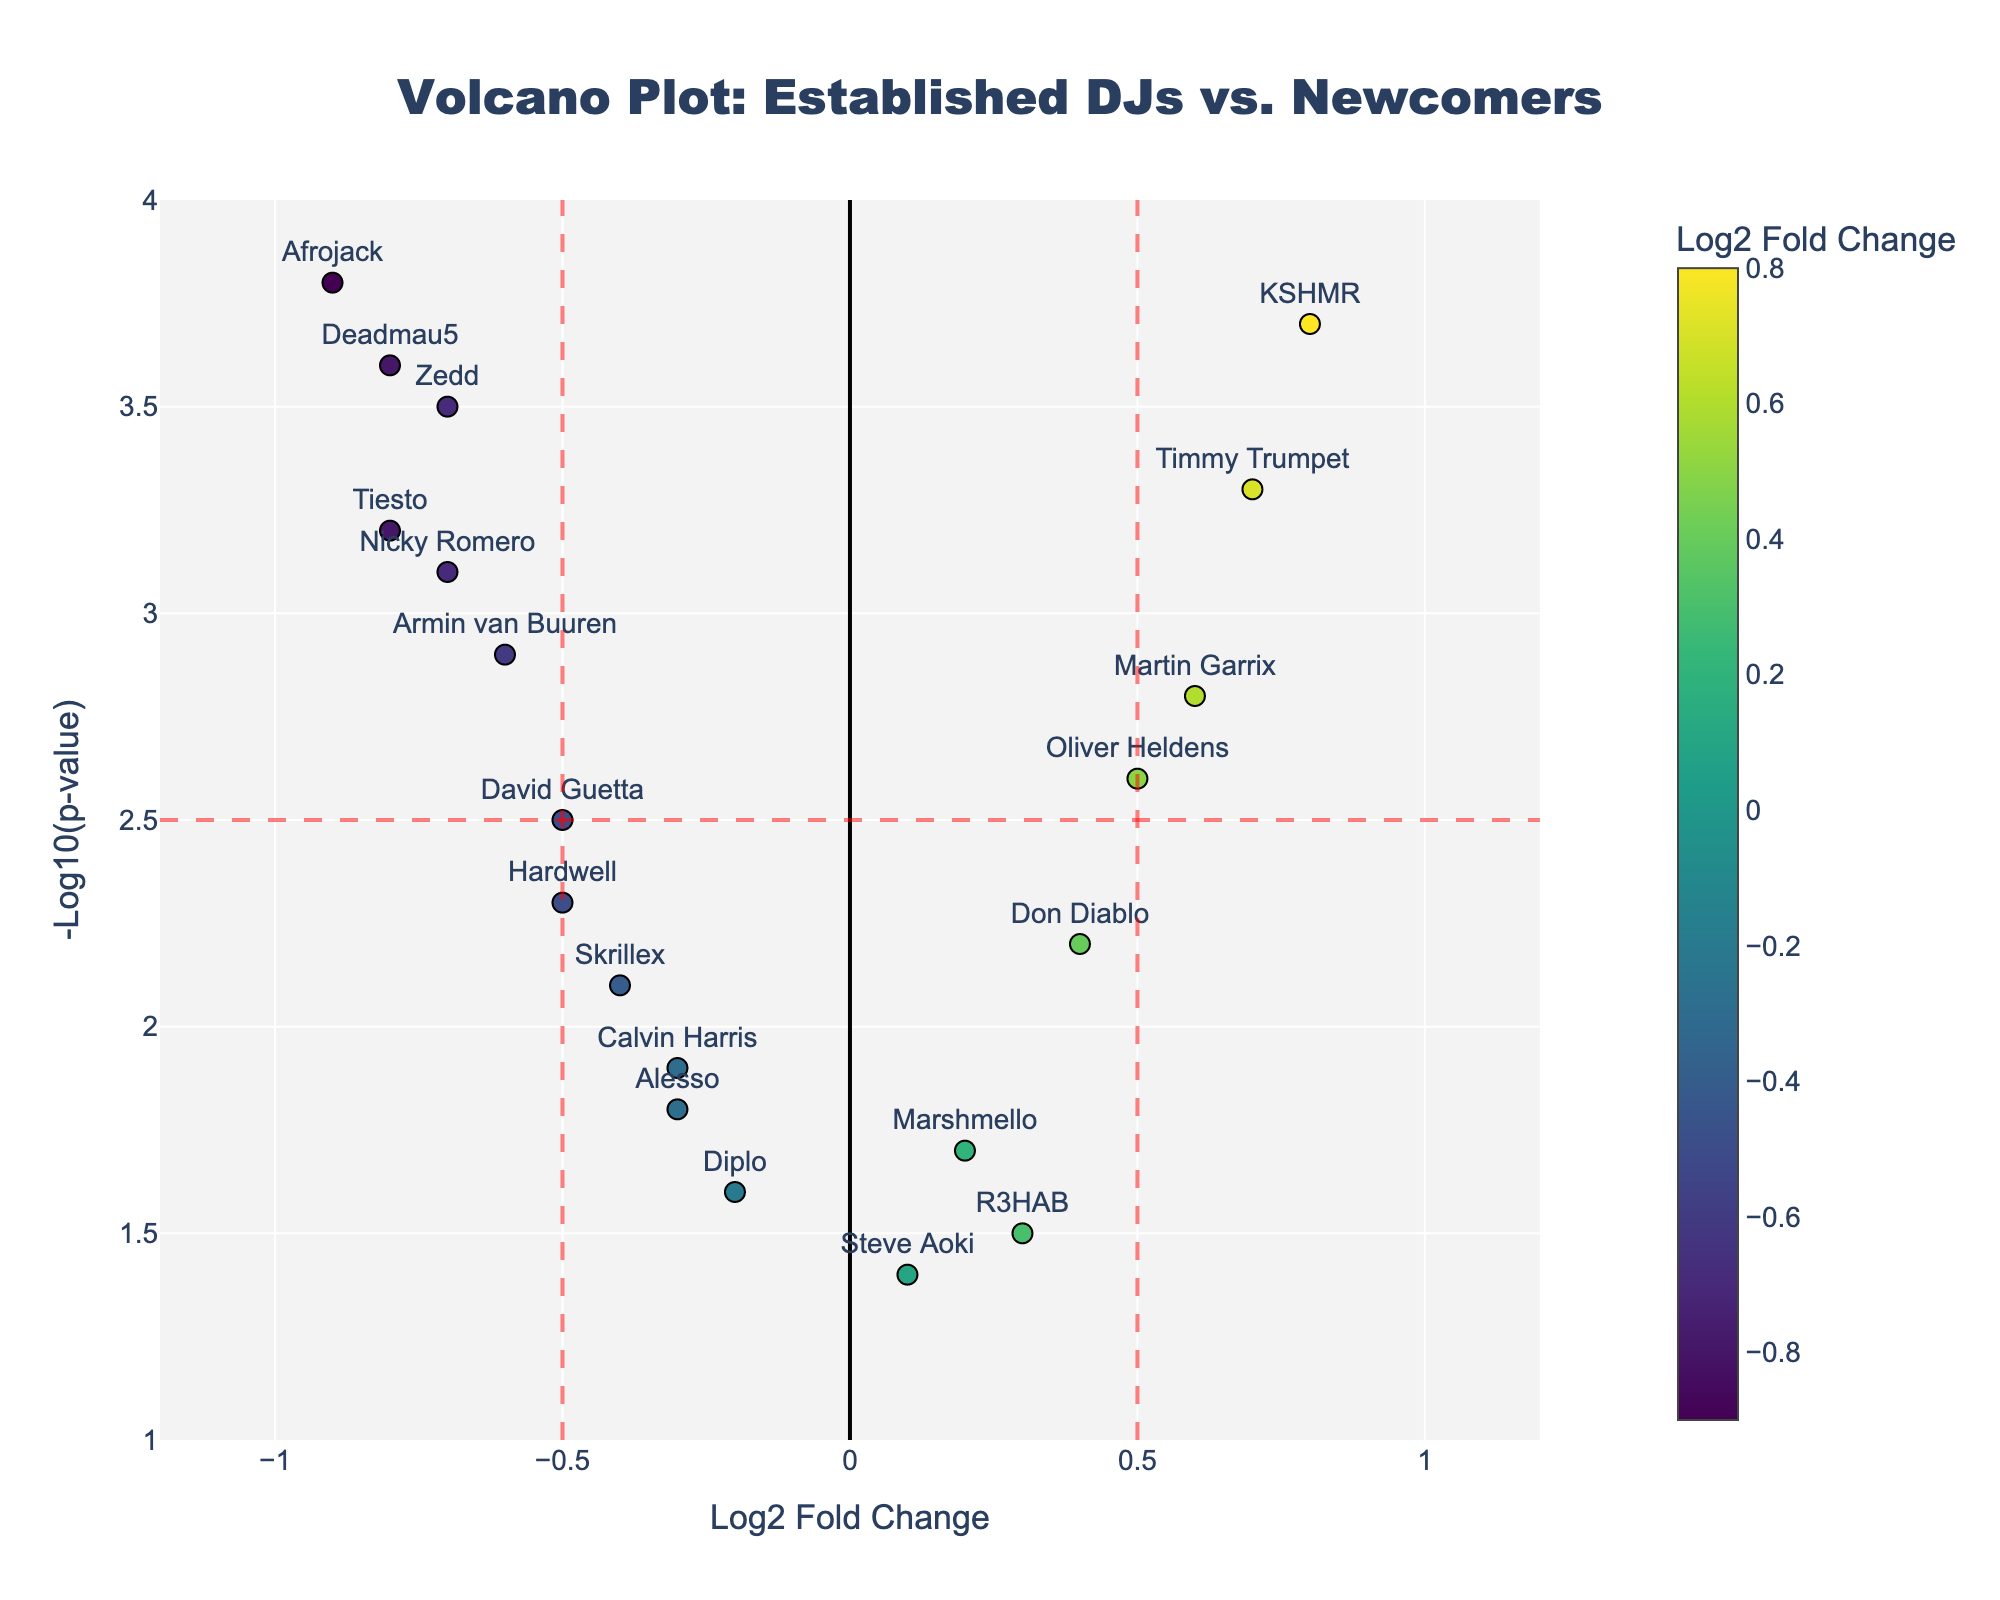What is the title of the figure? The title can be found at the top center of the plot, usually providing a summary of the data being visualized.
Answer: Volcano Plot: Established DJs vs. Newcomers How many DJs have a Log2 Fold Change greater than 0.5? Examine the x-axis and count the number of markers to the right of 0.5.
Answer: 2 Which DJ has the highest -Log10(p-value)? Check the highest point on the y-axis and read the text label next to it.
Answer: Afrojack What are the thresholds for Log2 Fold Change and -Log10(p-value)? Look for the dashed lines on both the x-axis and y-axis and read their values from the axis ticks.
Answer: Log2 Fold Change: ±0.5, -Log10(p-value): 2.5 How many DJs have statistically significant changes in engagement metrics? Count the markers that are above the horizontal red line (-Log10(p-value) threshold) and also fall outside the vertical lines (Log2 Fold Change threshold).
Answer: 9 Which is the top newcomer DJ based on positive Log2 Fold Change? Among the DJs with a Log2 Fold Change greater than 0.5, identify the one with the highest y-value (-Log10(p-value)) and read its label.
Answer: KSHMR Compare the Log2 Fold Change for Tiesto and Timmy Trumpet. Locate both Tiesto and Timmy Trumpet on the x-axis and note their positions; Tiesto is left (-0.8) and Timmy Trumpet is right (0.7).
Answer: Tiesto has a negative change, Timmy Trumpet has a positive change Which DJ has a greater -Log10(p-value), Martin Garrix or Don Diablo? Check the y-values for both DJs and compare them; Martin Garrix is at 2.8 and Don Diablo is at 2.2.
Answer: Martin Garrix How many data points are there in total? Count all the individual markers on the plot.
Answer: 20 What is the general trend for negative Log2 Fold Change in this plot? Observe the positions and the heights (y-values) of the markers on the left side of the x-axis.
Answer: Most established DJs have a higher -Log10(p-value) than newcomers 